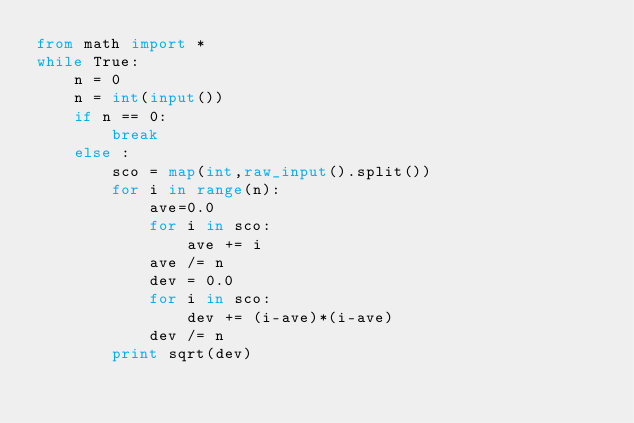Convert code to text. <code><loc_0><loc_0><loc_500><loc_500><_Python_>from math import *
while True:
    n = 0
    n = int(input())
    if n == 0:
        break
    else :
        sco = map(int,raw_input().split())
        for i in range(n):
            ave=0.0
            for i in sco:
                ave += i
            ave /= n
            dev = 0.0
            for i in sco:
                dev += (i-ave)*(i-ave)
            dev /= n
        print sqrt(dev)</code> 